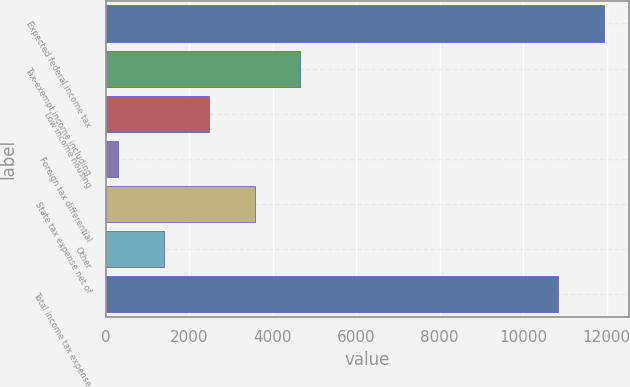Convert chart to OTSL. <chart><loc_0><loc_0><loc_500><loc_500><bar_chart><fcel>Expected federal income tax<fcel>Tax-exempt income including<fcel>Low income housing<fcel>Foreign tax differential<fcel>State tax expense net of<fcel>Other<fcel>Total income tax expense<nl><fcel>11930<fcel>4651<fcel>2471<fcel>291<fcel>3561<fcel>1381<fcel>10840<nl></chart> 